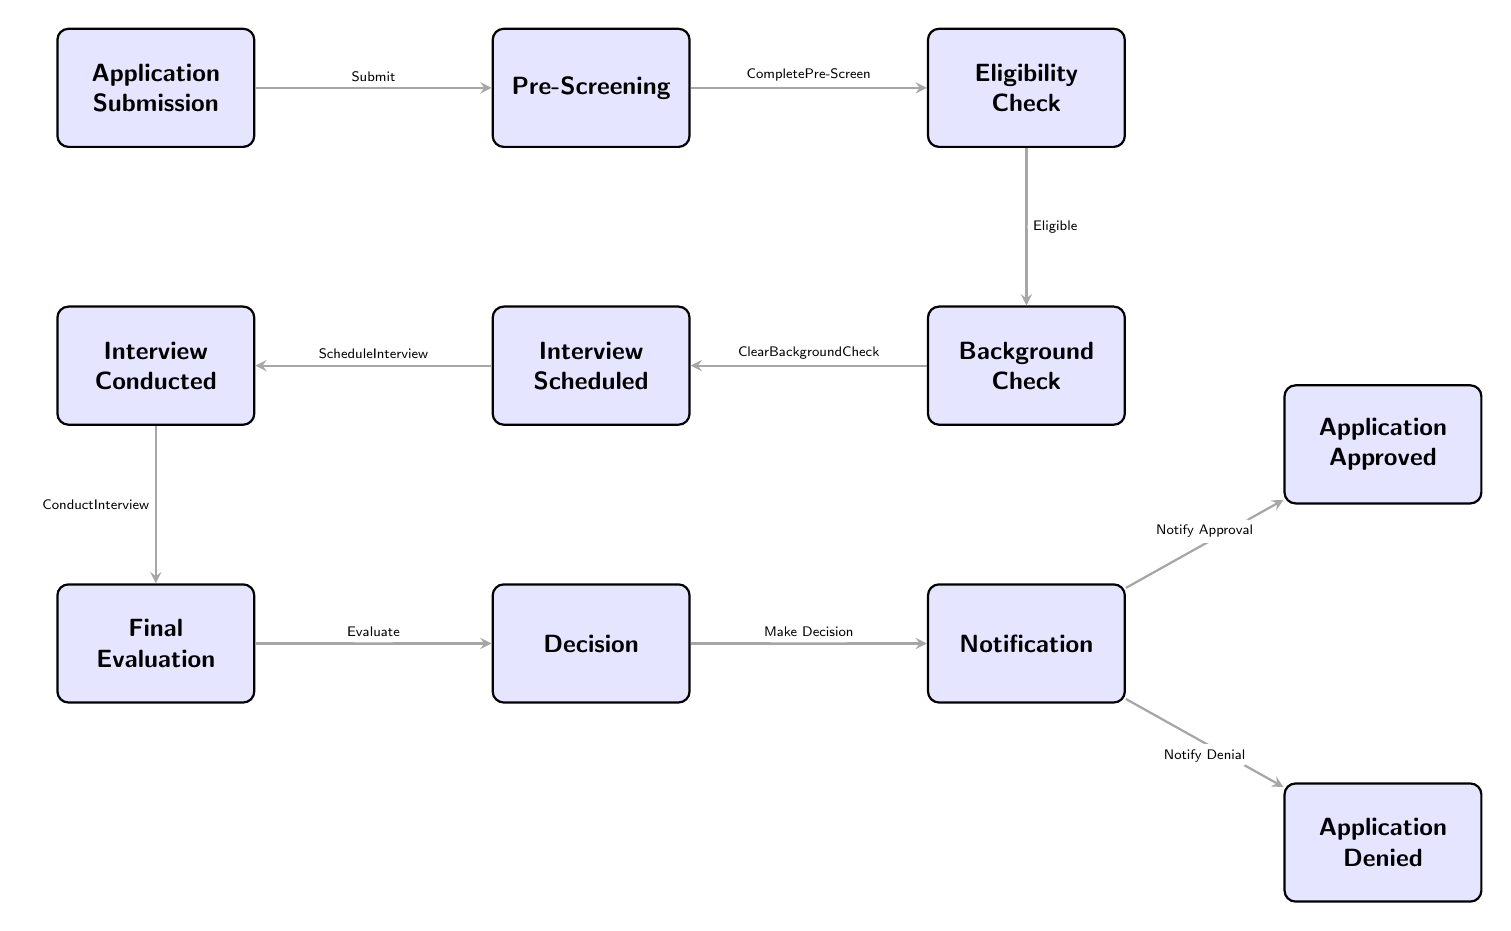What is the starting point of the workflow? The workflow begins with the node labeled "Application Submission." It is the first step in the diagram, indicated at the leftmost position, leading to the next step, Pre-Screening.
Answer: Application Submission How many decision points are there in the workflow? There are two decision points in the workflow. They are the "Decision" node, which leads to two outcomes, and the "Eligibility Check" node, which determines the next step based on eligibility.
Answer: 2 What happens after the Background Check? After the Background Check, the next step in the workflow is "Interview Scheduled." This is shown by the directed edge leading from the Background Check node to the Interview Scheduled node.
Answer: Interview Scheduled What are the two outcomes of the decision point? The two outcomes from the decision point are "Application Approved" and "Application Denied." They are indicated as branches from the Notification node following the decision.
Answer: Application Approved, Application Denied What is the flow of steps if the application is eligible? If the application is eligible, the workflow flows from "Eligibility Check" to "Background Check," then to "Interview Scheduled," followed by "Interview Conducted," "Final Evaluation," and finally to "Decision."
Answer: Background Check, Interview Scheduled, Interview Conducted, Final Evaluation, Decision 